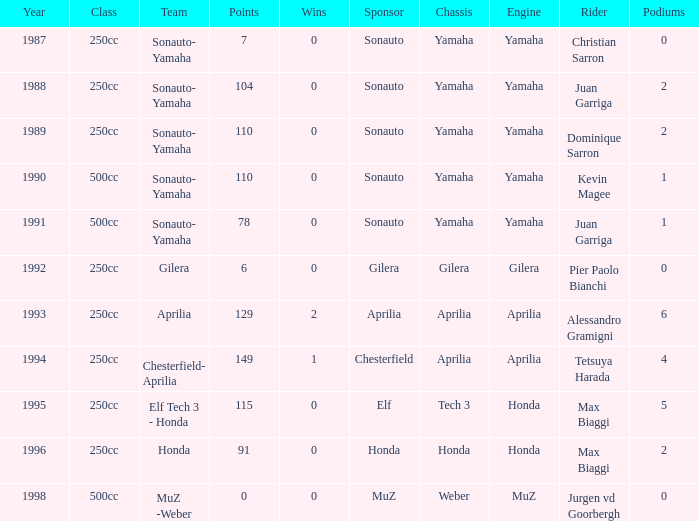What is the highest number of points the team with 0 wins had before 1992? 110.0. 